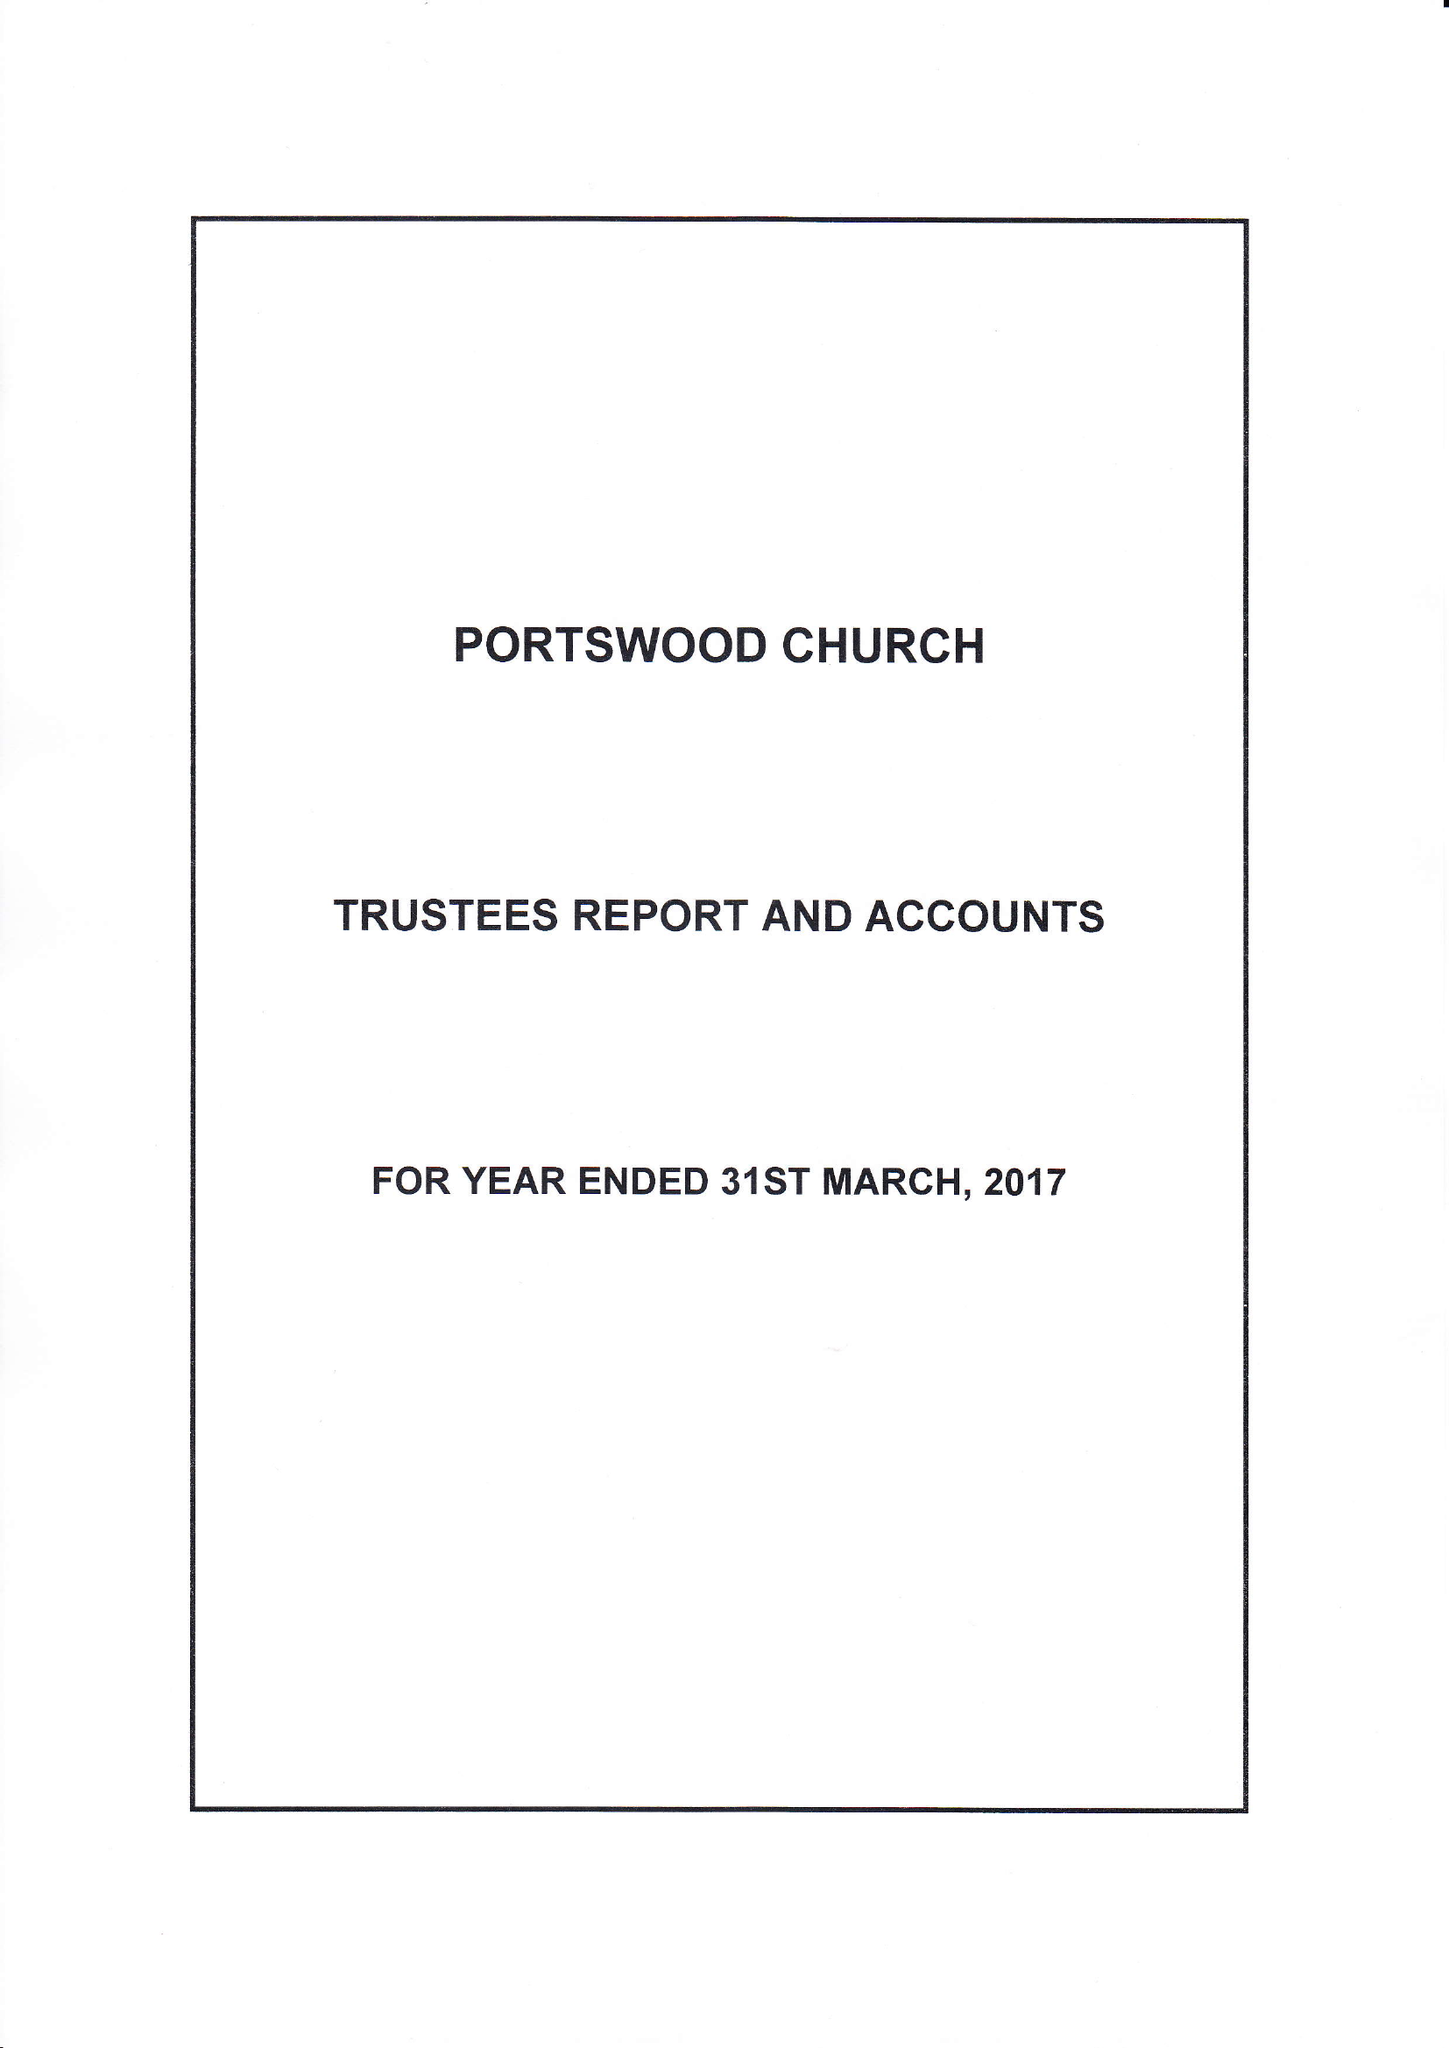What is the value for the address__street_line?
Answer the question using a single word or phrase. PORTSWOOD ROAD 